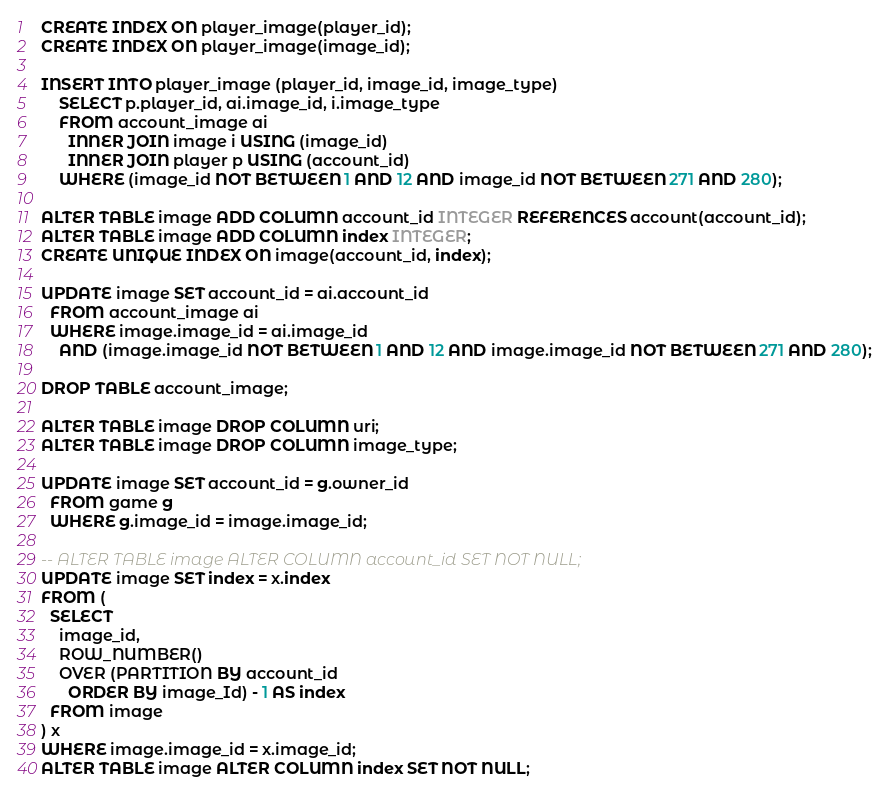<code> <loc_0><loc_0><loc_500><loc_500><_SQL_>CREATE INDEX ON player_image(player_id);
CREATE INDEX ON player_image(image_id);

INSERT INTO player_image (player_id, image_id, image_type)
    SELECT p.player_id, ai.image_id, i.image_type
    FROM account_image ai
      INNER JOIN image i USING (image_id)
      INNER JOIN player p USING (account_id)
    WHERE (image_id NOT BETWEEN 1 AND 12 AND image_id NOT BETWEEN 271 AND 280);

ALTER TABLE image ADD COLUMN account_id INTEGER REFERENCES account(account_id);
ALTER TABLE image ADD COLUMN index INTEGER;
CREATE UNIQUE INDEX ON image(account_id, index);

UPDATE image SET account_id = ai.account_id
  FROM account_image ai
  WHERE image.image_id = ai.image_id
    AND (image.image_id NOT BETWEEN 1 AND 12 AND image.image_id NOT BETWEEN 271 AND 280);

DROP TABLE account_image;

ALTER TABLE image DROP COLUMN uri;
ALTER TABLE image DROP COLUMN image_type;

UPDATE image SET account_id = g.owner_id
  FROM game g
  WHERE g.image_id = image.image_id;

-- ALTER TABLE image ALTER COLUMN account_id SET NOT NULL;
UPDATE image SET index = x.index
FROM (
  SELECT
    image_id,
    ROW_NUMBER()
    OVER (PARTITION BY account_id
      ORDER BY image_Id) - 1 AS index
  FROM image
) x
WHERE image.image_id = x.image_id;
ALTER TABLE image ALTER COLUMN index SET NOT NULL;
</code> 